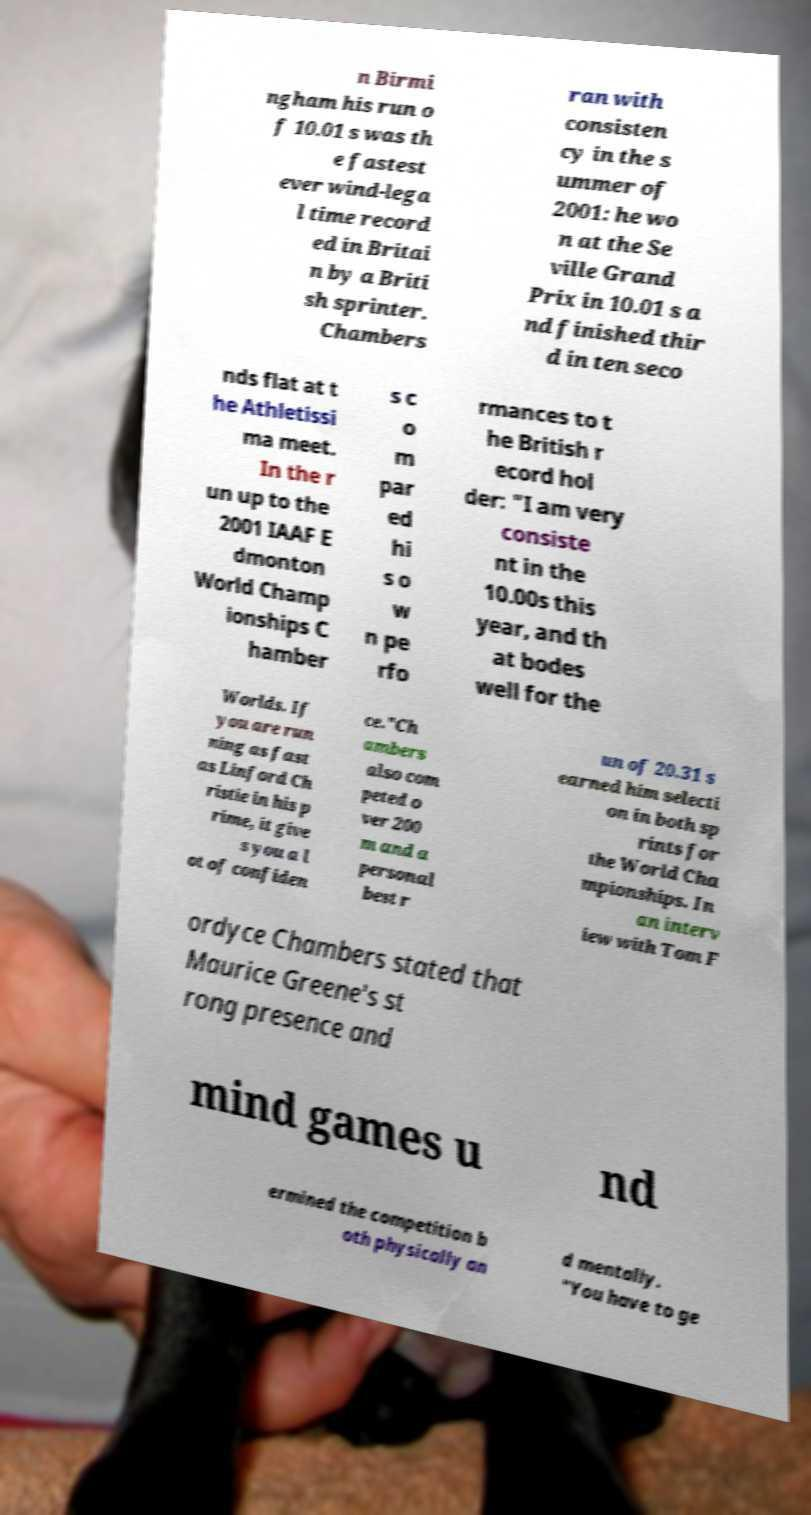What messages or text are displayed in this image? I need them in a readable, typed format. n Birmi ngham his run o f 10.01 s was th e fastest ever wind-lega l time record ed in Britai n by a Briti sh sprinter. Chambers ran with consisten cy in the s ummer of 2001: he wo n at the Se ville Grand Prix in 10.01 s a nd finished thir d in ten seco nds flat at t he Athletissi ma meet. In the r un up to the 2001 IAAF E dmonton World Champ ionships C hamber s c o m par ed hi s o w n pe rfo rmances to t he British r ecord hol der: "I am very consiste nt in the 10.00s this year, and th at bodes well for the Worlds. If you are run ning as fast as Linford Ch ristie in his p rime, it give s you a l ot of confiden ce."Ch ambers also com peted o ver 200 m and a personal best r un of 20.31 s earned him selecti on in both sp rints for the World Cha mpionships. In an interv iew with Tom F ordyce Chambers stated that Maurice Greene's st rong presence and mind games u nd ermined the competition b oth physically an d mentally. "You have to ge 